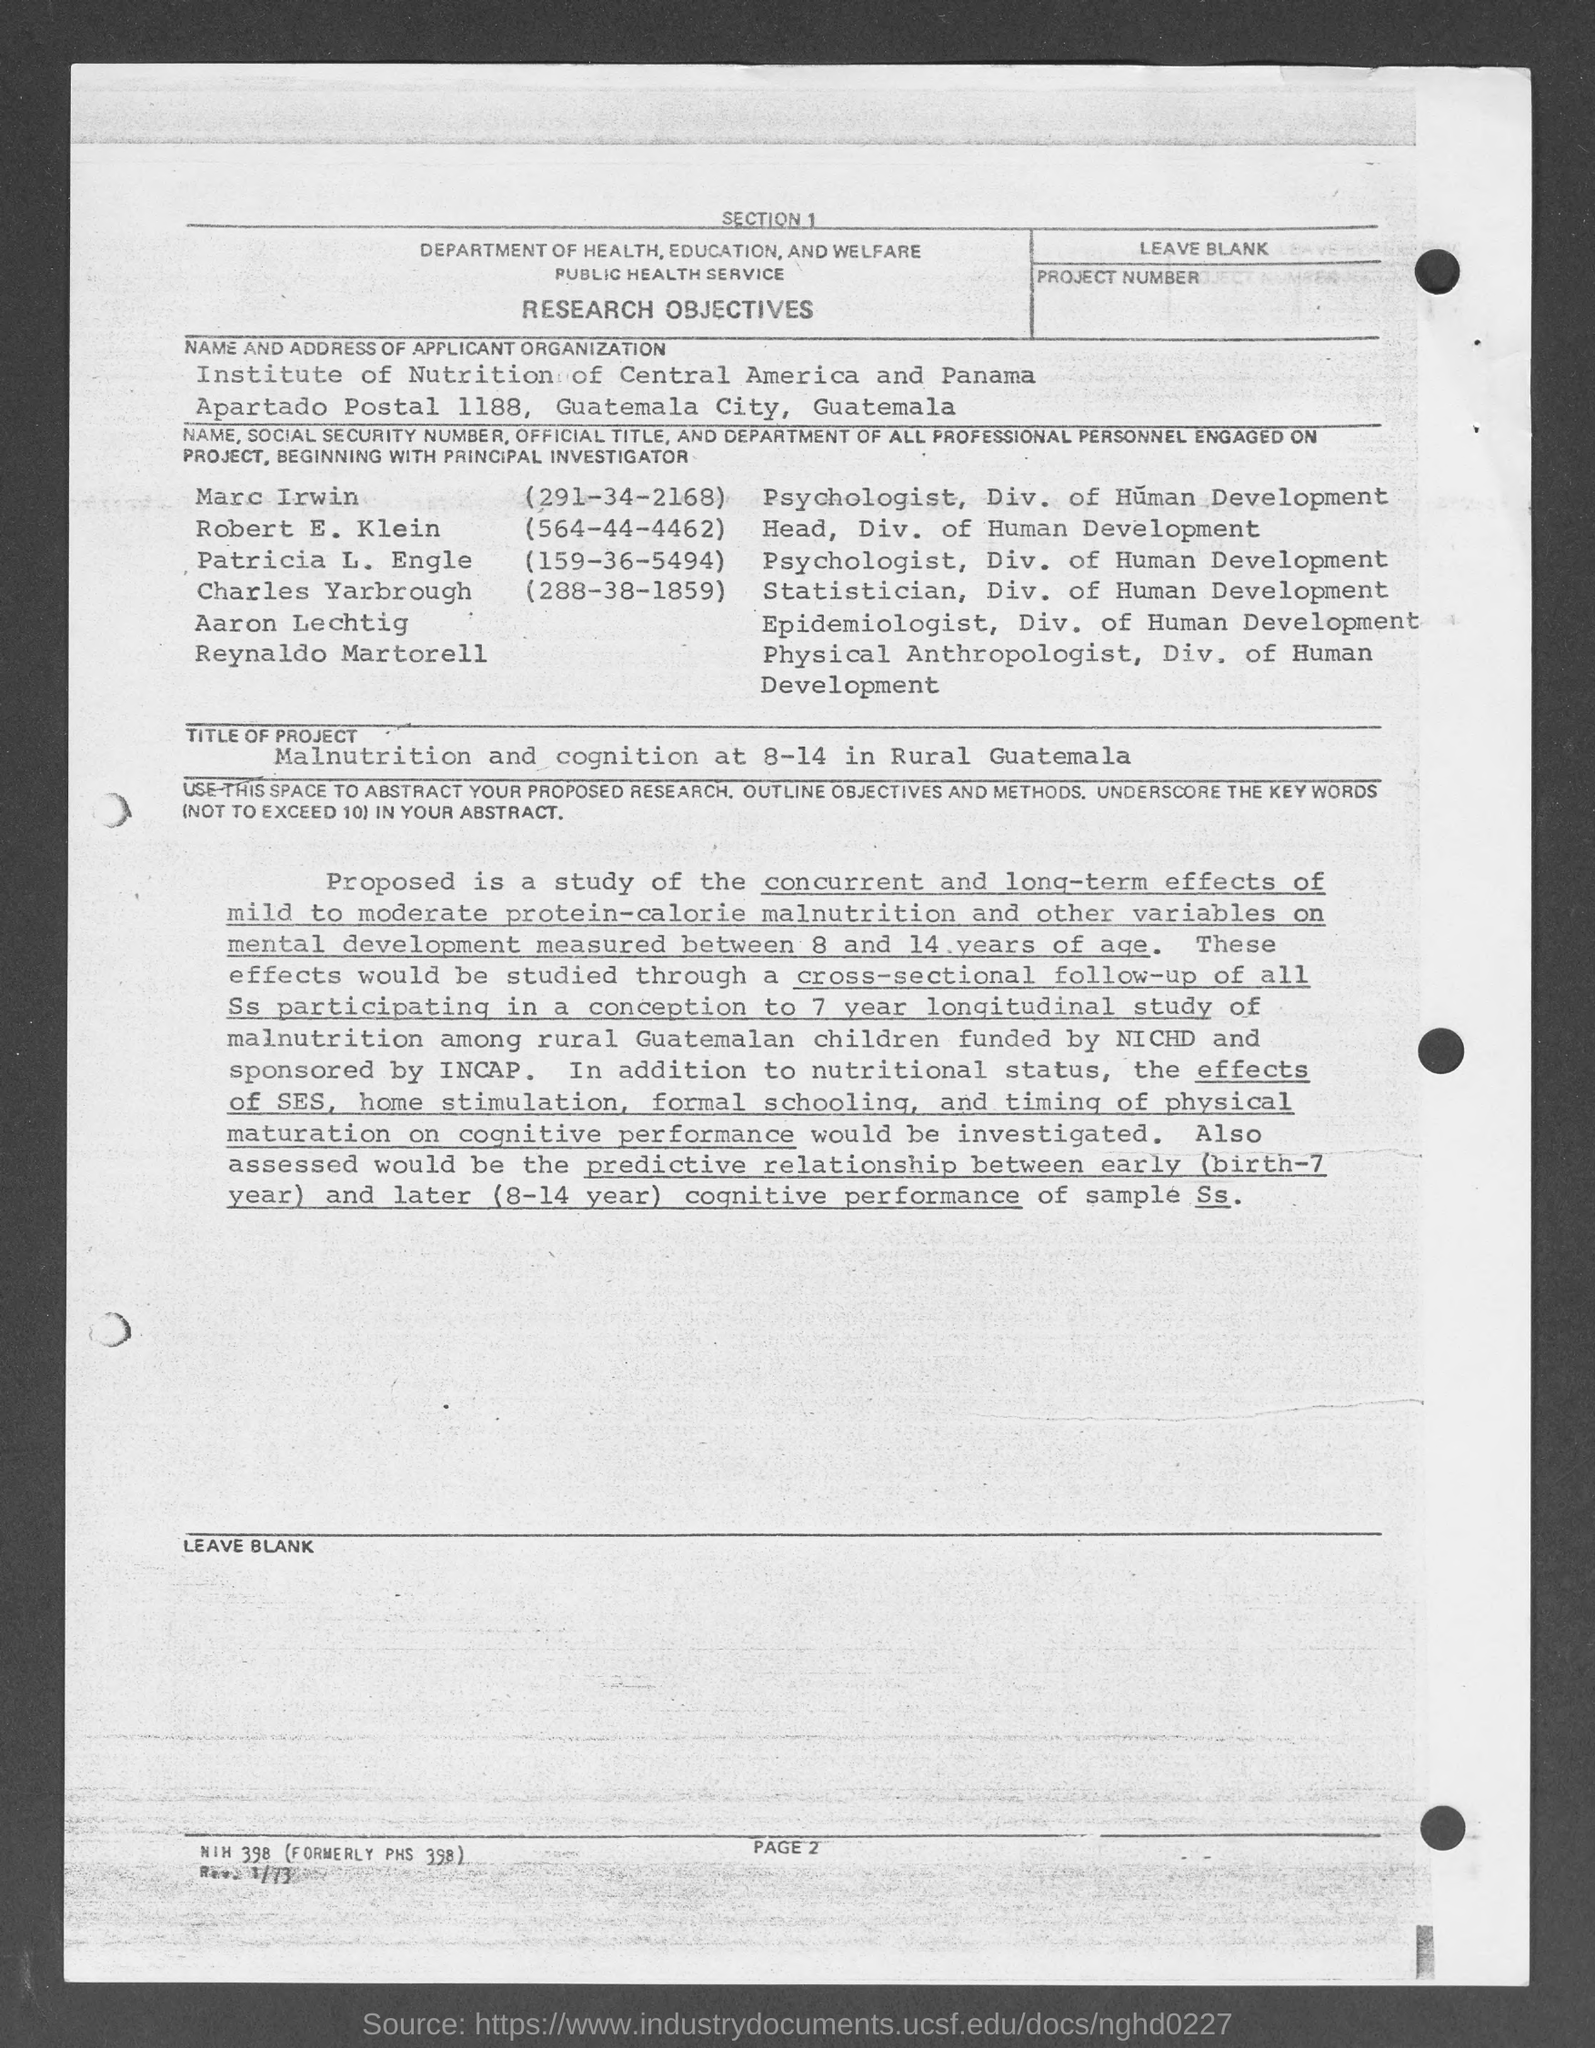List a handful of essential elements in this visual. The social security number of Marc Irwin is 291-34-2168. I am a resident of the United States of America. My name is Charles Yarbrough and my Social Security Number is 288-38-1859. I am a citizen of the United States, and I am 18 years old. I am a resident of the State of South Carolina. I am a citizen of the United States, and I am 18 years old. The Social Security Number of Patricia L. Engle is (159-36-5494). Robert E. Klein's Social Security Number is 564-44-4462. 